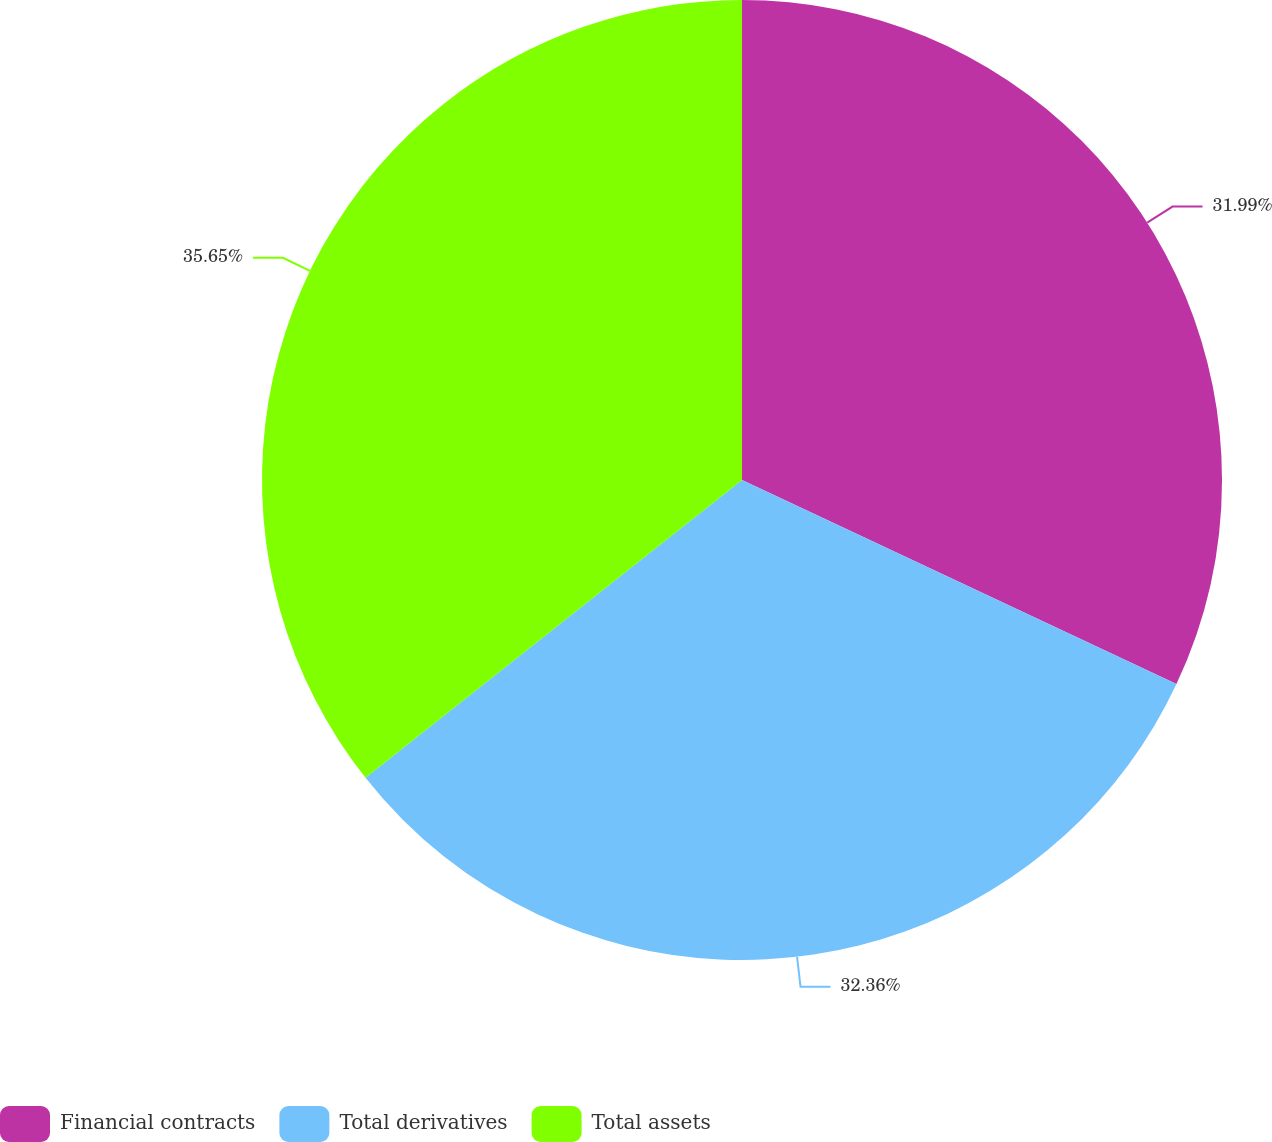Convert chart to OTSL. <chart><loc_0><loc_0><loc_500><loc_500><pie_chart><fcel>Financial contracts<fcel>Total derivatives<fcel>Total assets<nl><fcel>31.99%<fcel>32.36%<fcel>35.65%<nl></chart> 